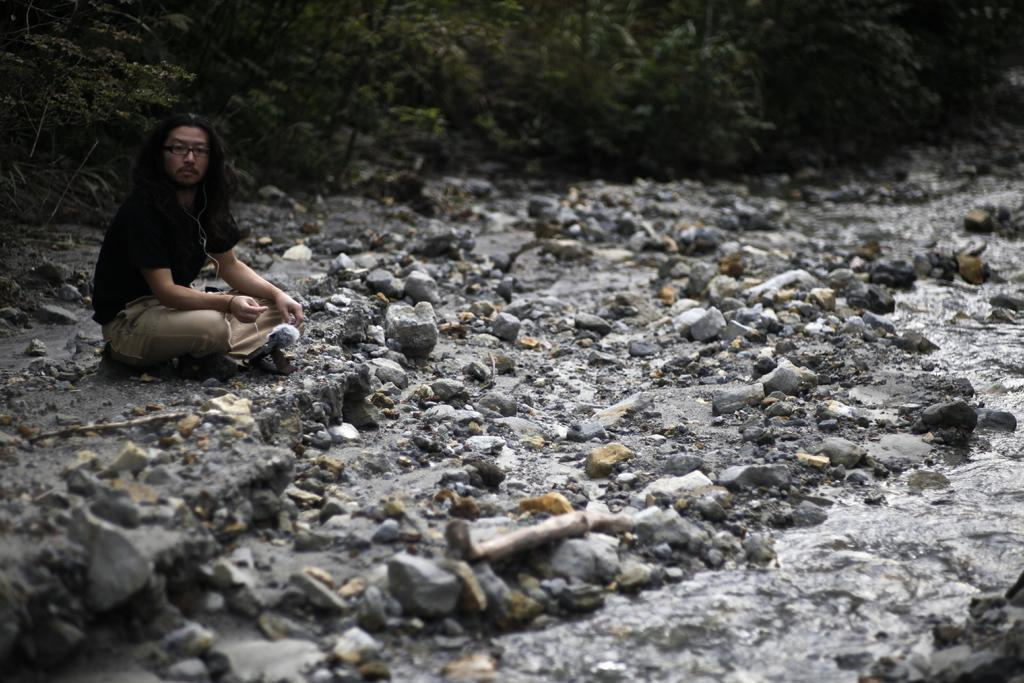What is the man in the image doing? The man is sitting on the ground in the image. What can be seen on the man's face in the image? The man is wearing spectacles in the image. What is visible in the background of the image? There are trees and water visible in the background of the image. What is on the ground where the man is sitting? There are stones on the ground in the image. What type of cheese is the man eating in the image? There is no cheese present in the image; the man is sitting on the ground with spectacles and surrounded by stones, trees, and water. What color is the honey dripping from the shoe in the image? There is no honey or shoe present in the image. 